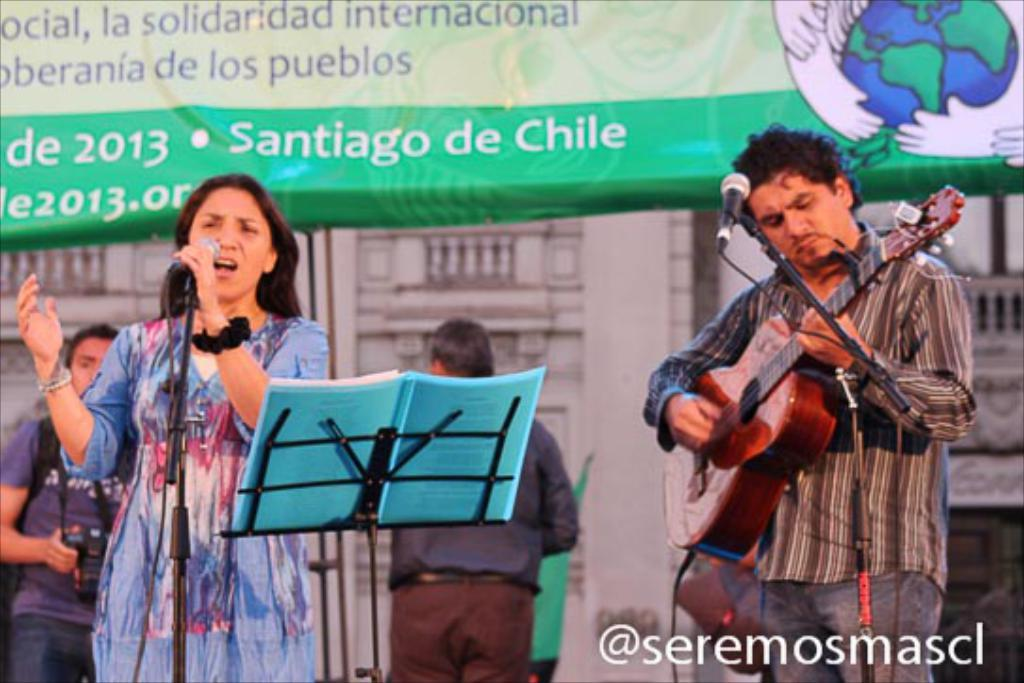Who are the people in the image? There is a woman and a man in the image. What is the man doing in the image? The man is standing and holding a guitar in his hand. What object is present in the image that is typically used for amplifying sound? There is a microphone in the image. What is hanging in the background of the image? There is a banner in the image. Is there any text or logo visible in the image? Yes, there is a watermark in the image. What type of protest is taking place in the image? There is no protest present in the image; it features a man holding a guitar and a woman. What is the level of friction between the man and the guitar in the image? The image does not provide information about the level of friction between the man and the guitar; it only shows the man holding the guitar. 